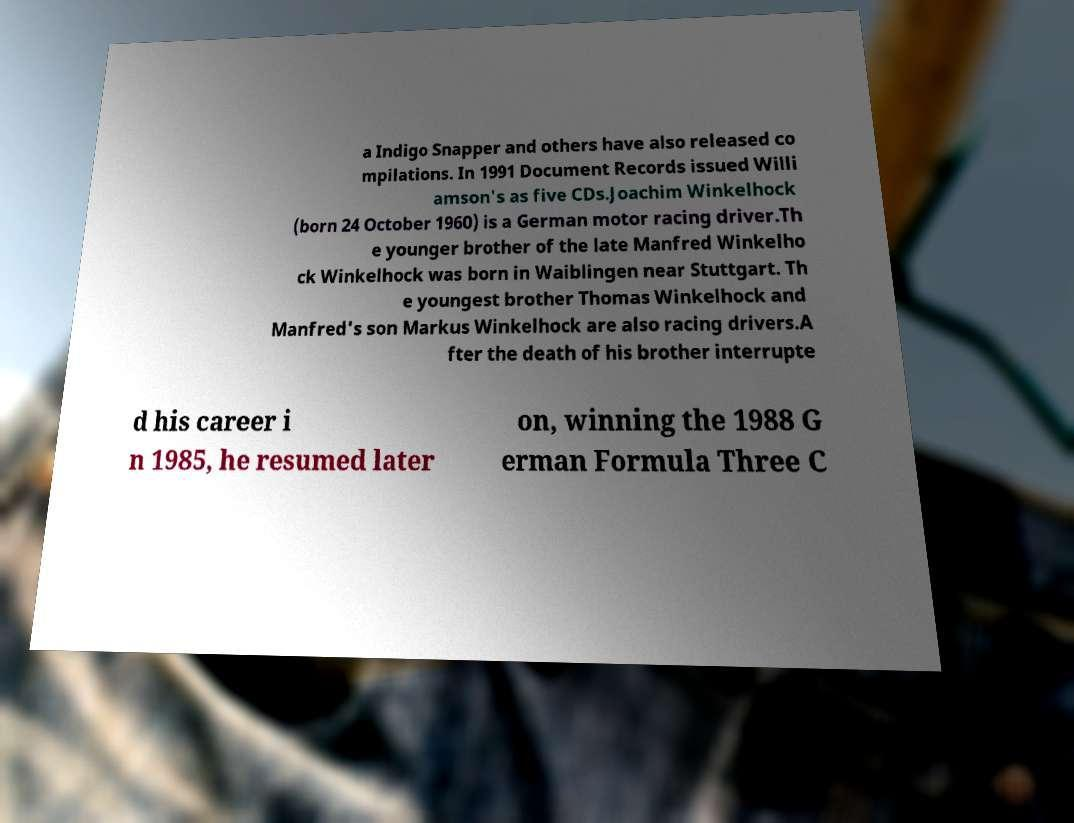Could you extract and type out the text from this image? a Indigo Snapper and others have also released co mpilations. In 1991 Document Records issued Willi amson's as five CDs.Joachim Winkelhock (born 24 October 1960) is a German motor racing driver.Th e younger brother of the late Manfred Winkelho ck Winkelhock was born in Waiblingen near Stuttgart. Th e youngest brother Thomas Winkelhock and Manfred's son Markus Winkelhock are also racing drivers.A fter the death of his brother interrupte d his career i n 1985, he resumed later on, winning the 1988 G erman Formula Three C 